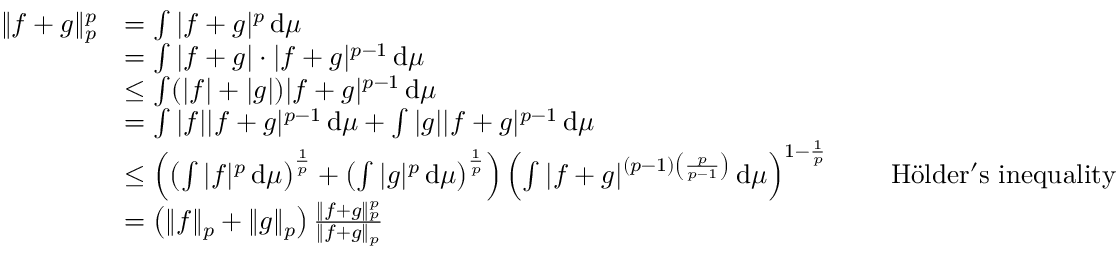Convert formula to latex. <formula><loc_0><loc_0><loc_500><loc_500>{ \begin{array} { r l r l } { \| f + g \| _ { p } ^ { p } } & { = \int | f + g | ^ { p } \, d \mu } \\ & { = \int | f + g | \cdot | f + g | ^ { p - 1 } \, d \mu } \\ & { \leq \int ( | f | + | g | ) | f + g | ^ { p - 1 } \, d \mu } \\ & { = \int | f | | f + g | ^ { p - 1 } \, d \mu + \int | g | | f + g | ^ { p - 1 } \, d \mu } \\ & { \leq \left ( \left ( \int | f | ^ { p } \, d \mu \right ) ^ { \frac { 1 } { p } } + \left ( \int | g | ^ { p } \, d \mu \right ) ^ { \frac { 1 } { p } } \right ) \left ( \int | f + g | ^ { ( p - 1 ) \left ( { \frac { p } { p - 1 } } \right ) } \, d \mu \right ) ^ { 1 - { \frac { 1 } { p } } } } & & { H l d e r ^ { \prime } s i n e q u a l i t y } \\ & { = \left ( \| f \| _ { p } + \| g \| _ { p } \right ) { \frac { \| f + g \| _ { p } ^ { p } } { \| f + g \| _ { p } } } } \end{array} }</formula> 